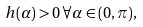<formula> <loc_0><loc_0><loc_500><loc_500>h ( \alpha ) > 0 \, \forall \alpha \in ( 0 , \pi ) ,</formula> 